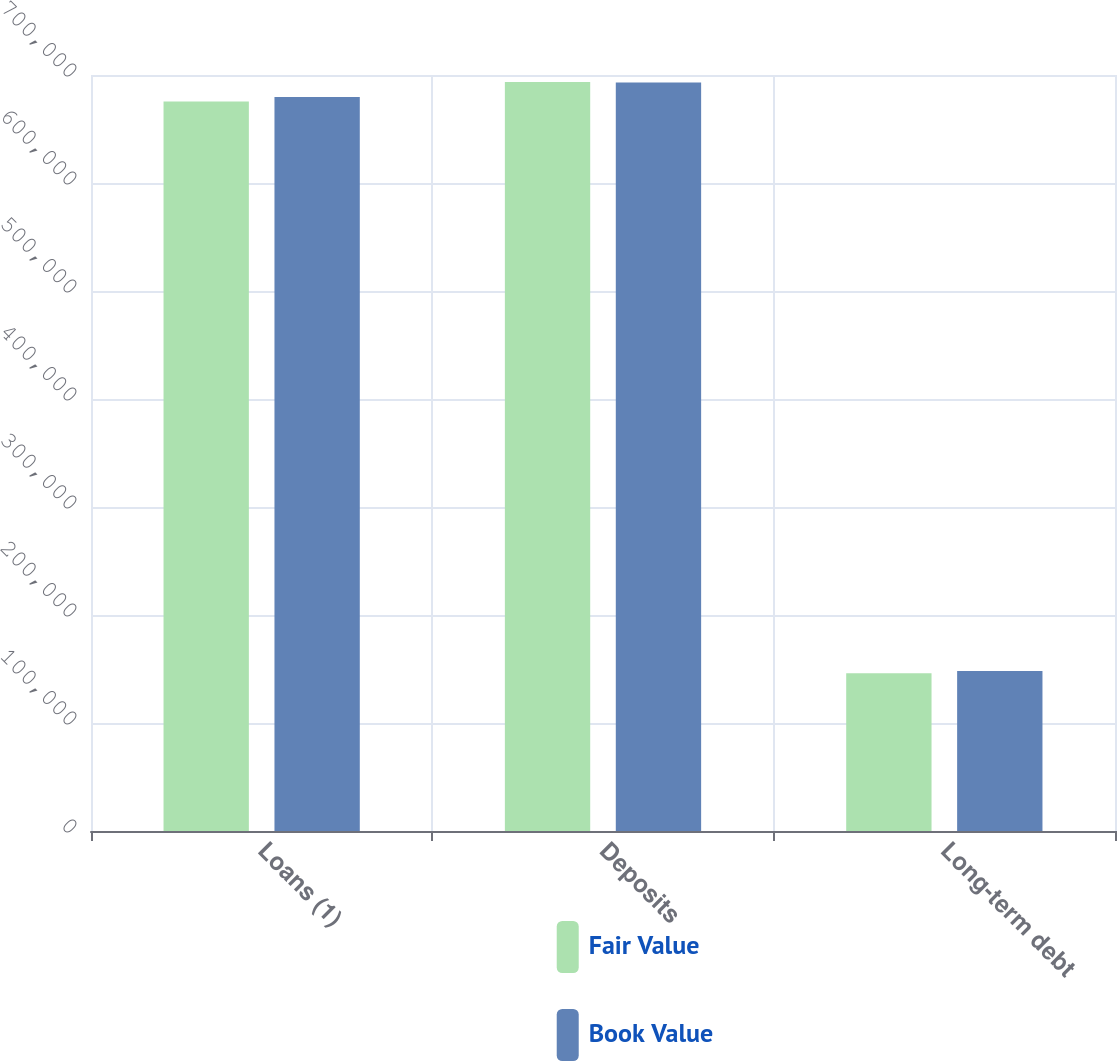<chart> <loc_0><loc_0><loc_500><loc_500><stacked_bar_chart><ecel><fcel>Loans (1)<fcel>Deposits<fcel>Long-term debt<nl><fcel>Fair Value<fcel>675544<fcel>693497<fcel>146000<nl><fcel>Book Value<fcel>679738<fcel>693041<fcel>148120<nl></chart> 